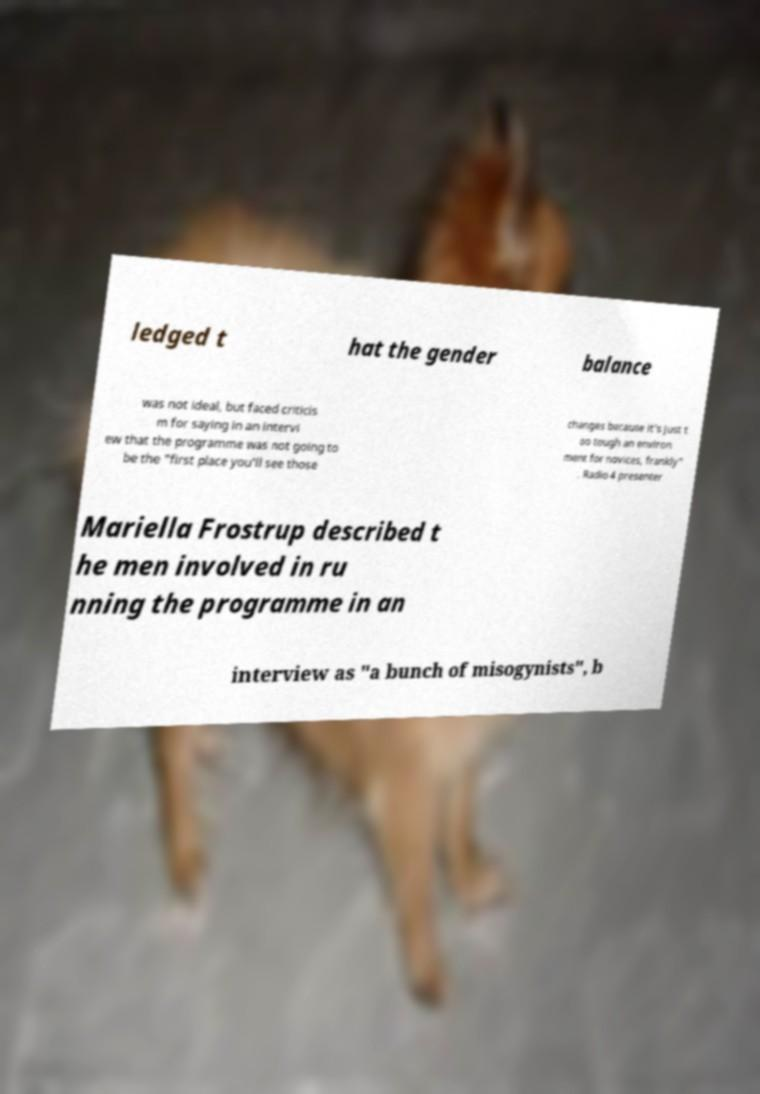Can you accurately transcribe the text from the provided image for me? ledged t hat the gender balance was not ideal, but faced criticis m for saying in an intervi ew that the programme was not going to be the "first place you'll see those changes because it's just t oo tough an environ ment for novices, frankly" . Radio 4 presenter Mariella Frostrup described t he men involved in ru nning the programme in an interview as "a bunch of misogynists", b 